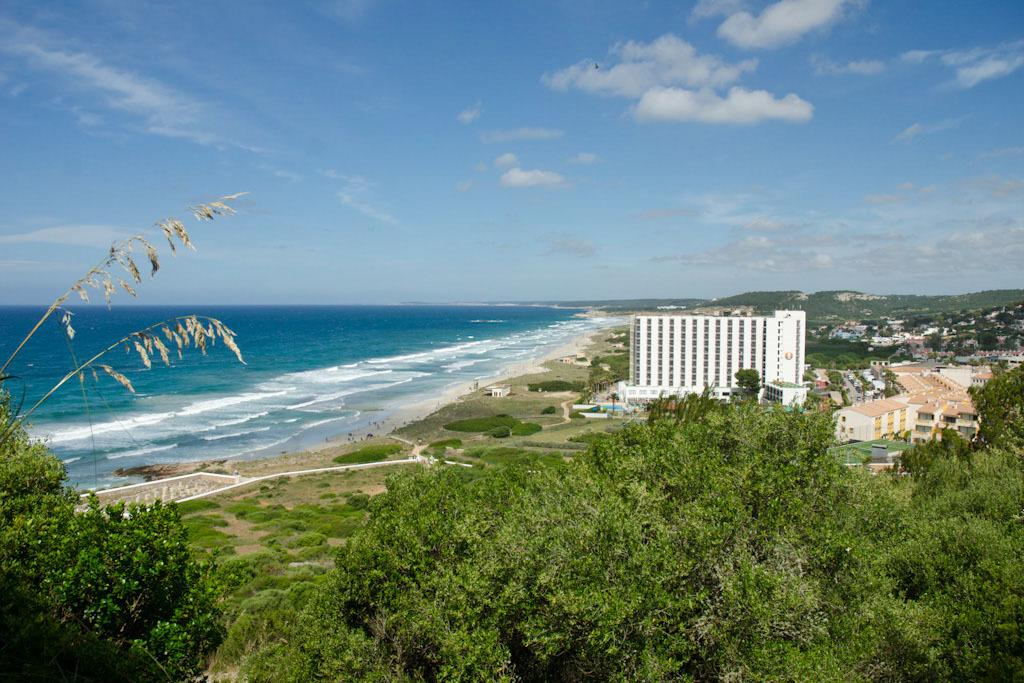What type of natural elements can be seen in the image? There are trees and water visible in the image. What type of man-made structures are present in the image? There are buildings in the image. What can be seen in the distance in the image? There are mountains in the background of the image. What part of the natural environment is visible in the image? The sky is visible in the image. Can you tell me which trees are wearing a crown in the image? There are no trees wearing a crown in the image. How does the comparison between the mountains and the buildings help us understand the image better? The image does not include a comparison between the mountains and the buildings, so we cannot use it to understand the image better. 